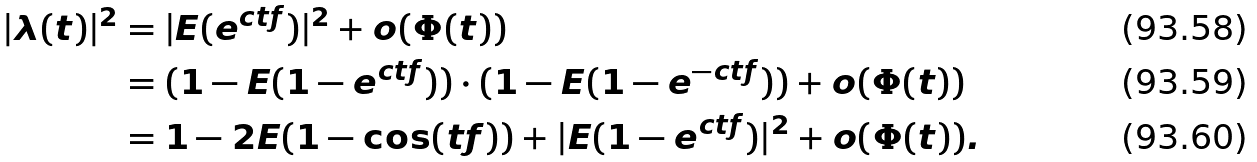<formula> <loc_0><loc_0><loc_500><loc_500>| \lambda ( t ) | ^ { 2 } & = | E ( e ^ { \i c t f } ) | ^ { 2 } + o ( \Phi ( t ) ) \\ & = ( 1 - E ( 1 - e ^ { \i c t f } ) ) \cdot ( 1 - E ( 1 - e ^ { - \i c t f } ) ) + o ( \Phi ( t ) ) \\ & = 1 - 2 E ( 1 - \cos ( t f ) ) + | E ( 1 - e ^ { \i c t f } ) | ^ { 2 } + o ( \Phi ( t ) ) .</formula> 